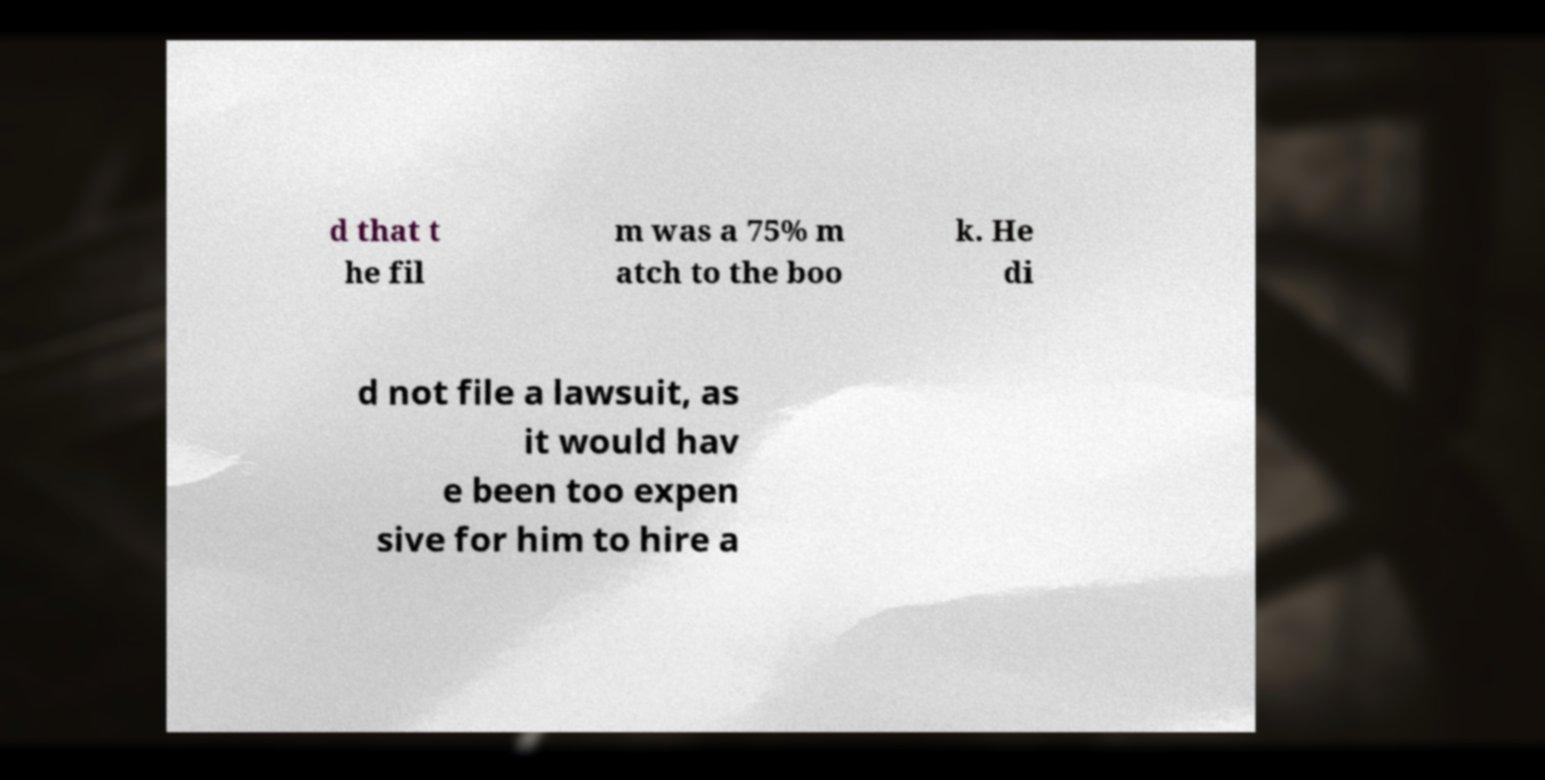Can you accurately transcribe the text from the provided image for me? d that t he fil m was a 75% m atch to the boo k. He di d not file a lawsuit, as it would hav e been too expen sive for him to hire a 